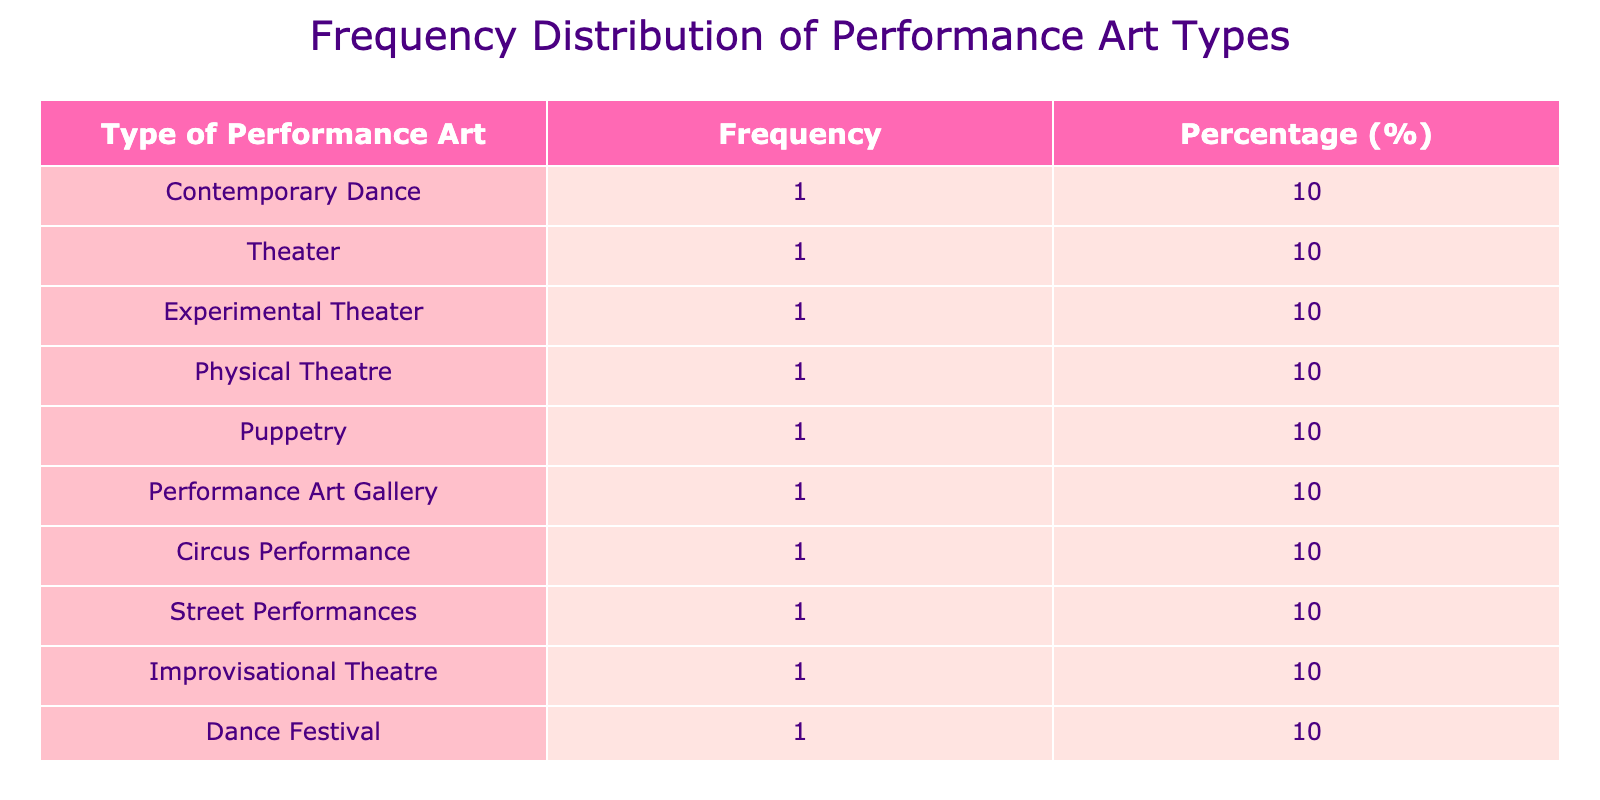What is the most attended type of performance art? The type of performance art with the highest attendance is Circus Performance, which had 500 attendees. This can be quickly identified by comparing the attendance figures in the table.
Answer: Circus Performance How many people attended Theater shows in total? The attendance for Theater shows is listed as 200. There is only one entry for Theater in the table, so the total attendance for this type is simply 200.
Answer: 200 What percentage of total attendance does Physical Theatre represent? There are 500 (Circus Performance) + 400 (Street Performances) + 300 (Physical Theatre) + other attendance sums. The total attendance is 500 + 400 + 300 + 150 + 200 + 120 + 80 + 220 + 90 + 350 = 2210. Physical Theatre had 300 attendees. To find the percentage, divide 300 by 2210 and multiply by 100, which gives approximately 13.57%.
Answer: 13.57% Is the attendance for Dance Festival higher than for Experimental Theater? The Dance Festival had an attendance of 350, whereas the Experimental Theater had 120 attendees. Comparing these two values, 350 is greater than 120, which means that Dance Festival's attendance is indeed higher.
Answer: Yes What is the average attendance for all performance art types? First, we add all attendance values: 150 + 200 + 120 + 300 + 80 + 220 + 500 + 400 + 90 + 350 = 2210. There are 10 different types of performance art, so we divide 2210 by 10. This results in an average attendance of 221.
Answer: 221 Which performance art type has the lowest attendance? The type with the lowest attendance is Puppetry, which had 80 attendees. By reviewing the attendance figures, 80 is clearly the smallest number among all listed types.
Answer: Puppetry Which type of performance art has an attendance greater than 200? The performance art types with attendance over 200 are Circus Performance (500), Street Performances (400), Dance Festival (350), and Performance Art Gallery (220). By checking each row's attendance, we can see which types meet this criterion.
Answer: Circus Performance, Street Performances, Dance Festival, Performance Art Gallery How many types of performance art have an attendance below the average? From our previous calculations, the average attendance is 221. The types with attendance below the average are Contemporary Dance (150), Experimental Theater (120), Puppetry (80), and Improvisational Theatre (90). This totals 4 types below the average.
Answer: 4 